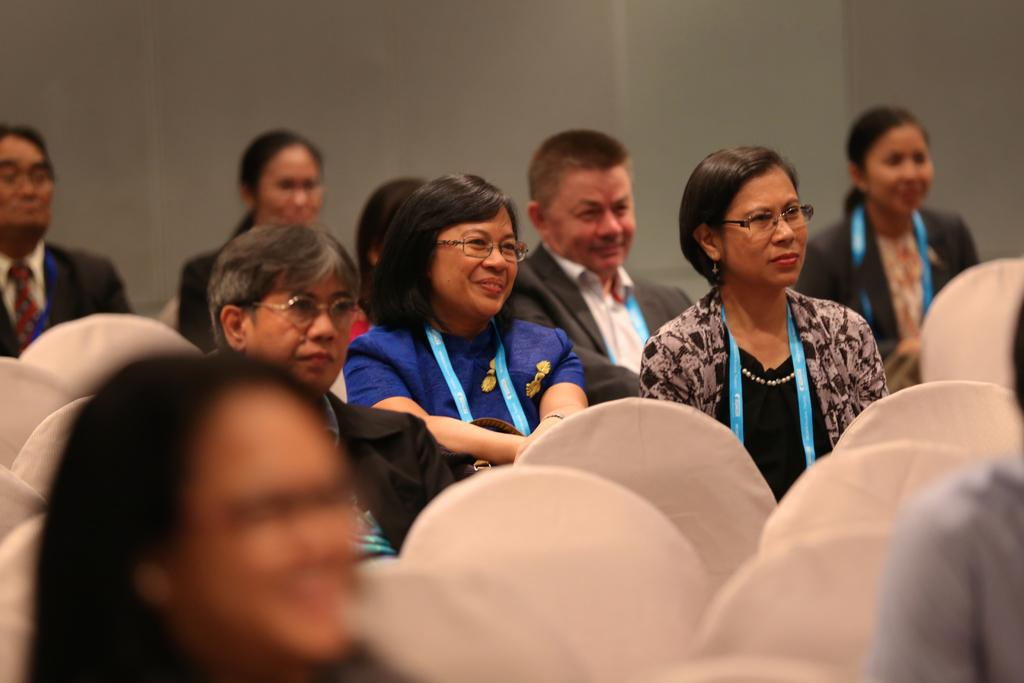Who or what is present in the image? There are people in the image. What are the people doing in the image? The people are sitting on chairs. What can be seen in the background of the image? There is a wall in the background of the image. Reasoning: Let' Let's think step by step in order to produce the conversation. We start by identifying the main subjects in the image, which are the people. Then, we describe their actions, noting that they are sitting on chairs. Finally, we mention the background of the image, which includes a wall. We avoid yes/no questions and ensure that the language is simple and clear. Absurd Question/Answer: Is the queen sitting on a chair made of quicksand in the image? There is no queen or quicksand present in the image; it features people sitting on chairs in front of a wall. 